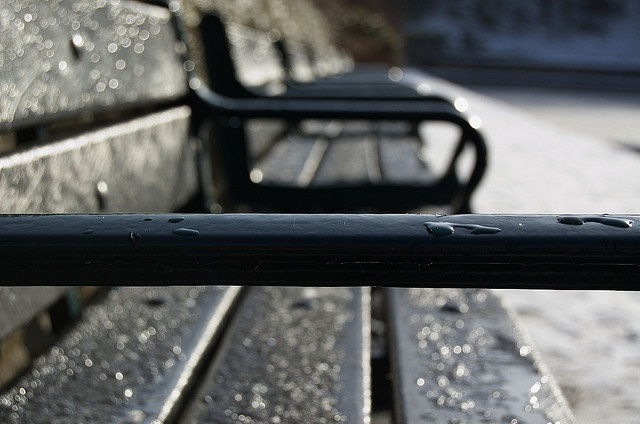Describe the objects in this image and their specific colors. I can see bench in darkgray, black, gray, and lightgray tones and bench in darkgray and gray tones in this image. 